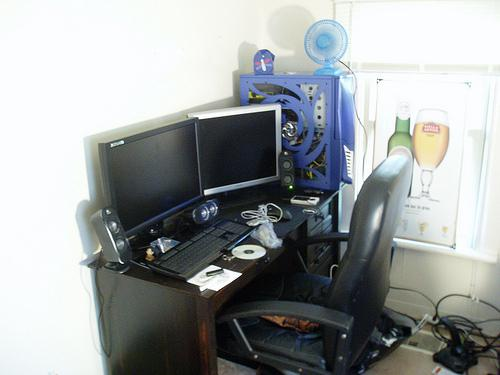Question: what is the color of the chair?
Choices:
A. Red.
B. Grey.
C. Black.
D. Brown.
Answer with the letter. Answer: C Question: who is sitting on the chair?
Choices:
A. Me.
B. My friend.
C. No one.
D. A woman.
Answer with the letter. Answer: C Question: why the computer is turned off?
Choices:
A. Work has been completed.
B. The user is too tired to go on.
C. No one is using.
D. It was an accident.
Answer with the letter. Answer: C Question: where is the computer?
Choices:
A. In the study.
B. In the kitchen.
C. On the table.
D. On the counter.
Answer with the letter. Answer: C Question: how many monitors on the table?
Choices:
A. 5.
B. 6.
C. 7.
D. 2.
Answer with the letter. Answer: D 